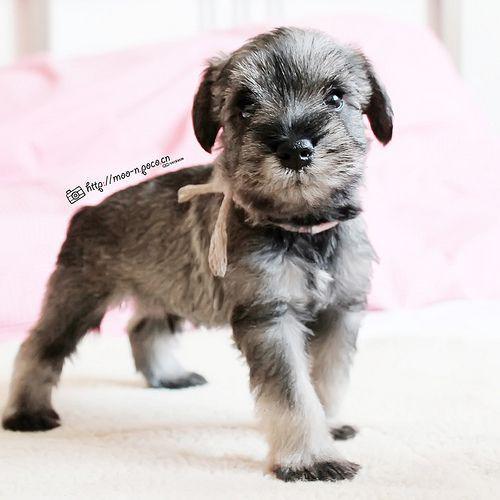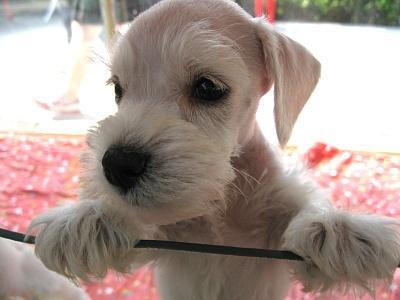The first image is the image on the left, the second image is the image on the right. Examine the images to the left and right. Is the description "The dog in the left image is in a standing pose with body turned to the right." accurate? Answer yes or no. Yes. 